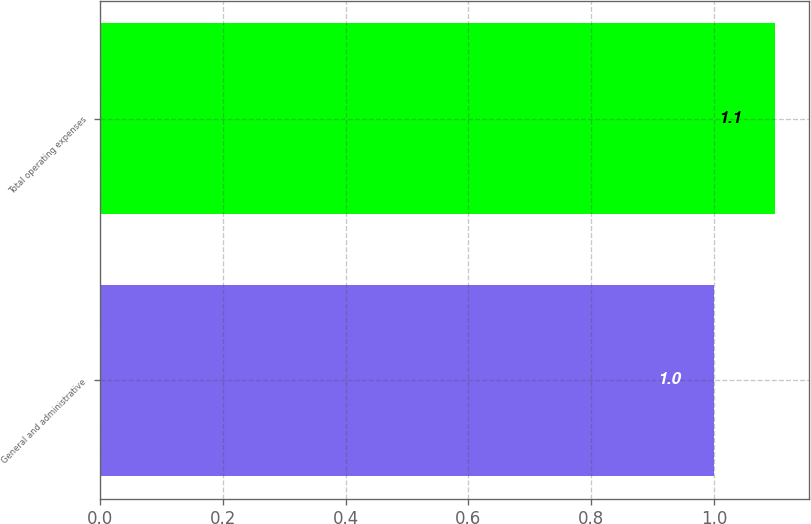Convert chart. <chart><loc_0><loc_0><loc_500><loc_500><bar_chart><fcel>General and administrative<fcel>Total operating expenses<nl><fcel>1<fcel>1.1<nl></chart> 